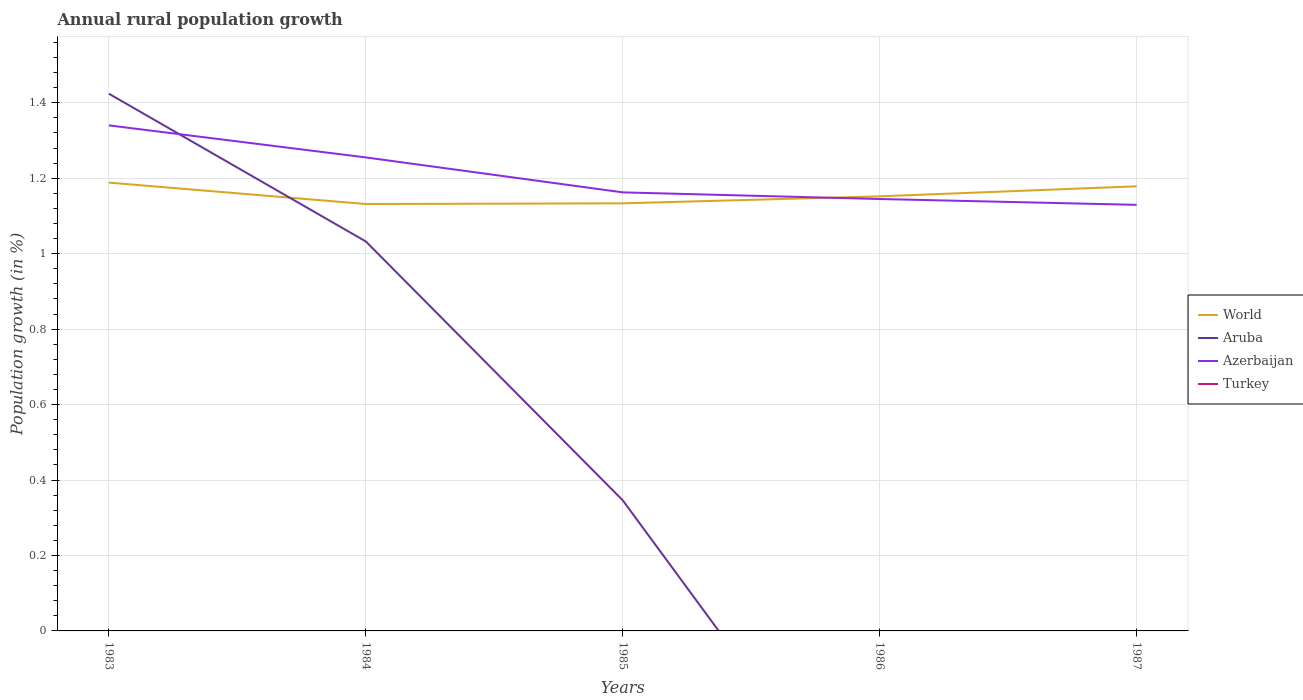How many different coloured lines are there?
Your answer should be very brief. 3. Is the number of lines equal to the number of legend labels?
Make the answer very short. No. Across all years, what is the maximum percentage of rural population growth in World?
Offer a terse response. 1.13. What is the total percentage of rural population growth in World in the graph?
Make the answer very short. 0.01. What is the difference between the highest and the second highest percentage of rural population growth in Aruba?
Provide a succinct answer. 1.42. What is the difference between the highest and the lowest percentage of rural population growth in Azerbaijan?
Your answer should be very brief. 2. How many lines are there?
Offer a terse response. 3. What is the difference between two consecutive major ticks on the Y-axis?
Your response must be concise. 0.2. Are the values on the major ticks of Y-axis written in scientific E-notation?
Your response must be concise. No. Does the graph contain any zero values?
Your answer should be compact. Yes. Where does the legend appear in the graph?
Your response must be concise. Center right. How are the legend labels stacked?
Your answer should be compact. Vertical. What is the title of the graph?
Offer a very short reply. Annual rural population growth. Does "Germany" appear as one of the legend labels in the graph?
Provide a succinct answer. No. What is the label or title of the X-axis?
Your answer should be compact. Years. What is the label or title of the Y-axis?
Keep it short and to the point. Population growth (in %). What is the Population growth (in %) of World in 1983?
Give a very brief answer. 1.19. What is the Population growth (in %) in Aruba in 1983?
Give a very brief answer. 1.42. What is the Population growth (in %) in Azerbaijan in 1983?
Provide a succinct answer. 1.34. What is the Population growth (in %) in World in 1984?
Give a very brief answer. 1.13. What is the Population growth (in %) of Aruba in 1984?
Provide a short and direct response. 1.03. What is the Population growth (in %) of Azerbaijan in 1984?
Offer a terse response. 1.26. What is the Population growth (in %) of World in 1985?
Offer a terse response. 1.13. What is the Population growth (in %) in Aruba in 1985?
Offer a terse response. 0.35. What is the Population growth (in %) of Azerbaijan in 1985?
Provide a short and direct response. 1.16. What is the Population growth (in %) of Turkey in 1985?
Your answer should be compact. 0. What is the Population growth (in %) in World in 1986?
Provide a succinct answer. 1.15. What is the Population growth (in %) in Azerbaijan in 1986?
Give a very brief answer. 1.14. What is the Population growth (in %) of World in 1987?
Provide a succinct answer. 1.18. What is the Population growth (in %) of Azerbaijan in 1987?
Provide a succinct answer. 1.13. Across all years, what is the maximum Population growth (in %) in World?
Your response must be concise. 1.19. Across all years, what is the maximum Population growth (in %) of Aruba?
Offer a very short reply. 1.42. Across all years, what is the maximum Population growth (in %) in Azerbaijan?
Give a very brief answer. 1.34. Across all years, what is the minimum Population growth (in %) in World?
Offer a very short reply. 1.13. Across all years, what is the minimum Population growth (in %) of Azerbaijan?
Your answer should be compact. 1.13. What is the total Population growth (in %) in World in the graph?
Your answer should be very brief. 5.78. What is the total Population growth (in %) of Aruba in the graph?
Provide a succinct answer. 2.8. What is the total Population growth (in %) in Azerbaijan in the graph?
Keep it short and to the point. 6.03. What is the difference between the Population growth (in %) of World in 1983 and that in 1984?
Give a very brief answer. 0.06. What is the difference between the Population growth (in %) in Aruba in 1983 and that in 1984?
Offer a very short reply. 0.39. What is the difference between the Population growth (in %) in Azerbaijan in 1983 and that in 1984?
Offer a terse response. 0.08. What is the difference between the Population growth (in %) of World in 1983 and that in 1985?
Your answer should be very brief. 0.05. What is the difference between the Population growth (in %) in Aruba in 1983 and that in 1985?
Provide a short and direct response. 1.08. What is the difference between the Population growth (in %) of Azerbaijan in 1983 and that in 1985?
Ensure brevity in your answer.  0.18. What is the difference between the Population growth (in %) of World in 1983 and that in 1986?
Provide a short and direct response. 0.04. What is the difference between the Population growth (in %) of Azerbaijan in 1983 and that in 1986?
Provide a short and direct response. 0.2. What is the difference between the Population growth (in %) of World in 1983 and that in 1987?
Provide a succinct answer. 0.01. What is the difference between the Population growth (in %) of Azerbaijan in 1983 and that in 1987?
Keep it short and to the point. 0.21. What is the difference between the Population growth (in %) in World in 1984 and that in 1985?
Ensure brevity in your answer.  -0. What is the difference between the Population growth (in %) of Aruba in 1984 and that in 1985?
Keep it short and to the point. 0.69. What is the difference between the Population growth (in %) of Azerbaijan in 1984 and that in 1985?
Your answer should be compact. 0.09. What is the difference between the Population growth (in %) of World in 1984 and that in 1986?
Your answer should be compact. -0.02. What is the difference between the Population growth (in %) of Azerbaijan in 1984 and that in 1986?
Keep it short and to the point. 0.11. What is the difference between the Population growth (in %) in World in 1984 and that in 1987?
Provide a succinct answer. -0.05. What is the difference between the Population growth (in %) in Azerbaijan in 1984 and that in 1987?
Your response must be concise. 0.13. What is the difference between the Population growth (in %) of World in 1985 and that in 1986?
Give a very brief answer. -0.02. What is the difference between the Population growth (in %) of Azerbaijan in 1985 and that in 1986?
Give a very brief answer. 0.02. What is the difference between the Population growth (in %) of World in 1985 and that in 1987?
Your response must be concise. -0.05. What is the difference between the Population growth (in %) in Azerbaijan in 1985 and that in 1987?
Your answer should be compact. 0.03. What is the difference between the Population growth (in %) of World in 1986 and that in 1987?
Your response must be concise. -0.03. What is the difference between the Population growth (in %) of Azerbaijan in 1986 and that in 1987?
Your response must be concise. 0.02. What is the difference between the Population growth (in %) of World in 1983 and the Population growth (in %) of Aruba in 1984?
Make the answer very short. 0.16. What is the difference between the Population growth (in %) of World in 1983 and the Population growth (in %) of Azerbaijan in 1984?
Your answer should be very brief. -0.07. What is the difference between the Population growth (in %) of Aruba in 1983 and the Population growth (in %) of Azerbaijan in 1984?
Make the answer very short. 0.17. What is the difference between the Population growth (in %) of World in 1983 and the Population growth (in %) of Aruba in 1985?
Keep it short and to the point. 0.84. What is the difference between the Population growth (in %) of World in 1983 and the Population growth (in %) of Azerbaijan in 1985?
Keep it short and to the point. 0.03. What is the difference between the Population growth (in %) of Aruba in 1983 and the Population growth (in %) of Azerbaijan in 1985?
Provide a succinct answer. 0.26. What is the difference between the Population growth (in %) of World in 1983 and the Population growth (in %) of Azerbaijan in 1986?
Provide a succinct answer. 0.04. What is the difference between the Population growth (in %) in Aruba in 1983 and the Population growth (in %) in Azerbaijan in 1986?
Make the answer very short. 0.28. What is the difference between the Population growth (in %) in World in 1983 and the Population growth (in %) in Azerbaijan in 1987?
Keep it short and to the point. 0.06. What is the difference between the Population growth (in %) of Aruba in 1983 and the Population growth (in %) of Azerbaijan in 1987?
Keep it short and to the point. 0.29. What is the difference between the Population growth (in %) in World in 1984 and the Population growth (in %) in Aruba in 1985?
Keep it short and to the point. 0.79. What is the difference between the Population growth (in %) of World in 1984 and the Population growth (in %) of Azerbaijan in 1985?
Provide a short and direct response. -0.03. What is the difference between the Population growth (in %) of Aruba in 1984 and the Population growth (in %) of Azerbaijan in 1985?
Offer a terse response. -0.13. What is the difference between the Population growth (in %) in World in 1984 and the Population growth (in %) in Azerbaijan in 1986?
Keep it short and to the point. -0.01. What is the difference between the Population growth (in %) in Aruba in 1984 and the Population growth (in %) in Azerbaijan in 1986?
Make the answer very short. -0.11. What is the difference between the Population growth (in %) of World in 1984 and the Population growth (in %) of Azerbaijan in 1987?
Your answer should be compact. 0. What is the difference between the Population growth (in %) of Aruba in 1984 and the Population growth (in %) of Azerbaijan in 1987?
Ensure brevity in your answer.  -0.1. What is the difference between the Population growth (in %) in World in 1985 and the Population growth (in %) in Azerbaijan in 1986?
Your answer should be compact. -0.01. What is the difference between the Population growth (in %) in Aruba in 1985 and the Population growth (in %) in Azerbaijan in 1986?
Your response must be concise. -0.8. What is the difference between the Population growth (in %) in World in 1985 and the Population growth (in %) in Azerbaijan in 1987?
Make the answer very short. 0. What is the difference between the Population growth (in %) in Aruba in 1985 and the Population growth (in %) in Azerbaijan in 1987?
Ensure brevity in your answer.  -0.78. What is the difference between the Population growth (in %) of World in 1986 and the Population growth (in %) of Azerbaijan in 1987?
Provide a succinct answer. 0.02. What is the average Population growth (in %) of World per year?
Your answer should be very brief. 1.16. What is the average Population growth (in %) of Aruba per year?
Your answer should be compact. 0.56. What is the average Population growth (in %) of Azerbaijan per year?
Keep it short and to the point. 1.21. In the year 1983, what is the difference between the Population growth (in %) of World and Population growth (in %) of Aruba?
Provide a short and direct response. -0.24. In the year 1983, what is the difference between the Population growth (in %) of World and Population growth (in %) of Azerbaijan?
Provide a succinct answer. -0.15. In the year 1983, what is the difference between the Population growth (in %) in Aruba and Population growth (in %) in Azerbaijan?
Provide a short and direct response. 0.08. In the year 1984, what is the difference between the Population growth (in %) in World and Population growth (in %) in Aruba?
Ensure brevity in your answer.  0.1. In the year 1984, what is the difference between the Population growth (in %) in World and Population growth (in %) in Azerbaijan?
Provide a short and direct response. -0.12. In the year 1984, what is the difference between the Population growth (in %) in Aruba and Population growth (in %) in Azerbaijan?
Your answer should be very brief. -0.22. In the year 1985, what is the difference between the Population growth (in %) of World and Population growth (in %) of Aruba?
Your response must be concise. 0.79. In the year 1985, what is the difference between the Population growth (in %) of World and Population growth (in %) of Azerbaijan?
Give a very brief answer. -0.03. In the year 1985, what is the difference between the Population growth (in %) of Aruba and Population growth (in %) of Azerbaijan?
Give a very brief answer. -0.82. In the year 1986, what is the difference between the Population growth (in %) in World and Population growth (in %) in Azerbaijan?
Make the answer very short. 0.01. In the year 1987, what is the difference between the Population growth (in %) in World and Population growth (in %) in Azerbaijan?
Ensure brevity in your answer.  0.05. What is the ratio of the Population growth (in %) in World in 1983 to that in 1984?
Give a very brief answer. 1.05. What is the ratio of the Population growth (in %) in Aruba in 1983 to that in 1984?
Keep it short and to the point. 1.38. What is the ratio of the Population growth (in %) of Azerbaijan in 1983 to that in 1984?
Provide a short and direct response. 1.07. What is the ratio of the Population growth (in %) in World in 1983 to that in 1985?
Provide a succinct answer. 1.05. What is the ratio of the Population growth (in %) of Aruba in 1983 to that in 1985?
Make the answer very short. 4.12. What is the ratio of the Population growth (in %) in Azerbaijan in 1983 to that in 1985?
Ensure brevity in your answer.  1.15. What is the ratio of the Population growth (in %) of World in 1983 to that in 1986?
Provide a succinct answer. 1.03. What is the ratio of the Population growth (in %) of Azerbaijan in 1983 to that in 1986?
Ensure brevity in your answer.  1.17. What is the ratio of the Population growth (in %) of World in 1983 to that in 1987?
Your response must be concise. 1.01. What is the ratio of the Population growth (in %) of Azerbaijan in 1983 to that in 1987?
Make the answer very short. 1.19. What is the ratio of the Population growth (in %) in World in 1984 to that in 1985?
Provide a short and direct response. 1. What is the ratio of the Population growth (in %) in Aruba in 1984 to that in 1985?
Offer a very short reply. 2.98. What is the ratio of the Population growth (in %) of Azerbaijan in 1984 to that in 1985?
Provide a succinct answer. 1.08. What is the ratio of the Population growth (in %) in World in 1984 to that in 1986?
Offer a terse response. 0.98. What is the ratio of the Population growth (in %) in Azerbaijan in 1984 to that in 1986?
Provide a short and direct response. 1.1. What is the ratio of the Population growth (in %) of World in 1984 to that in 1987?
Your answer should be very brief. 0.96. What is the ratio of the Population growth (in %) in Azerbaijan in 1984 to that in 1987?
Ensure brevity in your answer.  1.11. What is the ratio of the Population growth (in %) of World in 1985 to that in 1986?
Offer a terse response. 0.98. What is the ratio of the Population growth (in %) of Azerbaijan in 1985 to that in 1986?
Provide a short and direct response. 1.02. What is the ratio of the Population growth (in %) of World in 1985 to that in 1987?
Keep it short and to the point. 0.96. What is the ratio of the Population growth (in %) in Azerbaijan in 1985 to that in 1987?
Make the answer very short. 1.03. What is the ratio of the Population growth (in %) in World in 1986 to that in 1987?
Provide a succinct answer. 0.98. What is the ratio of the Population growth (in %) in Azerbaijan in 1986 to that in 1987?
Keep it short and to the point. 1.01. What is the difference between the highest and the second highest Population growth (in %) in World?
Provide a short and direct response. 0.01. What is the difference between the highest and the second highest Population growth (in %) of Aruba?
Keep it short and to the point. 0.39. What is the difference between the highest and the second highest Population growth (in %) in Azerbaijan?
Ensure brevity in your answer.  0.08. What is the difference between the highest and the lowest Population growth (in %) of World?
Provide a short and direct response. 0.06. What is the difference between the highest and the lowest Population growth (in %) in Aruba?
Your answer should be very brief. 1.42. What is the difference between the highest and the lowest Population growth (in %) of Azerbaijan?
Make the answer very short. 0.21. 